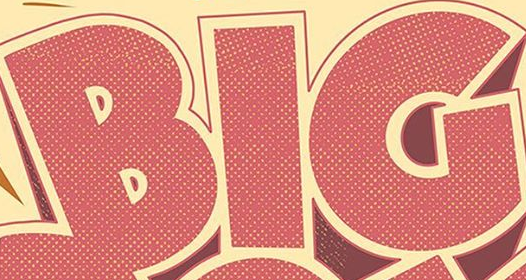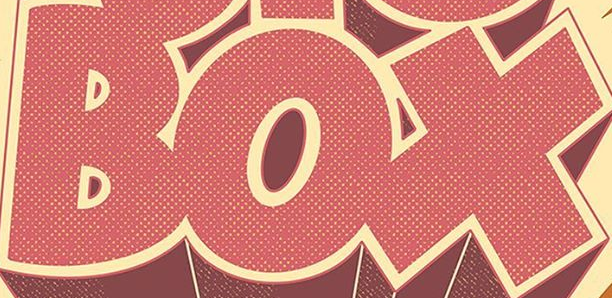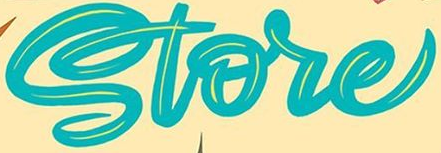Read the text content from these images in order, separated by a semicolon. BIG; BOX; Store 